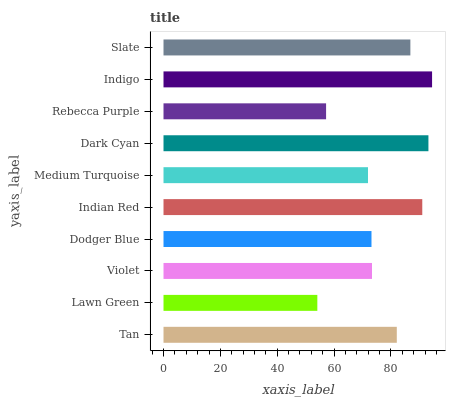Is Lawn Green the minimum?
Answer yes or no. Yes. Is Indigo the maximum?
Answer yes or no. Yes. Is Violet the minimum?
Answer yes or no. No. Is Violet the maximum?
Answer yes or no. No. Is Violet greater than Lawn Green?
Answer yes or no. Yes. Is Lawn Green less than Violet?
Answer yes or no. Yes. Is Lawn Green greater than Violet?
Answer yes or no. No. Is Violet less than Lawn Green?
Answer yes or no. No. Is Tan the high median?
Answer yes or no. Yes. Is Violet the low median?
Answer yes or no. Yes. Is Dodger Blue the high median?
Answer yes or no. No. Is Indian Red the low median?
Answer yes or no. No. 